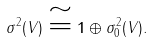<formula> <loc_0><loc_0><loc_500><loc_500>\sigma ^ { 2 } ( V ) \cong { \mathbf 1 } \oplus \sigma ^ { 2 } _ { 0 } ( V ) .</formula> 